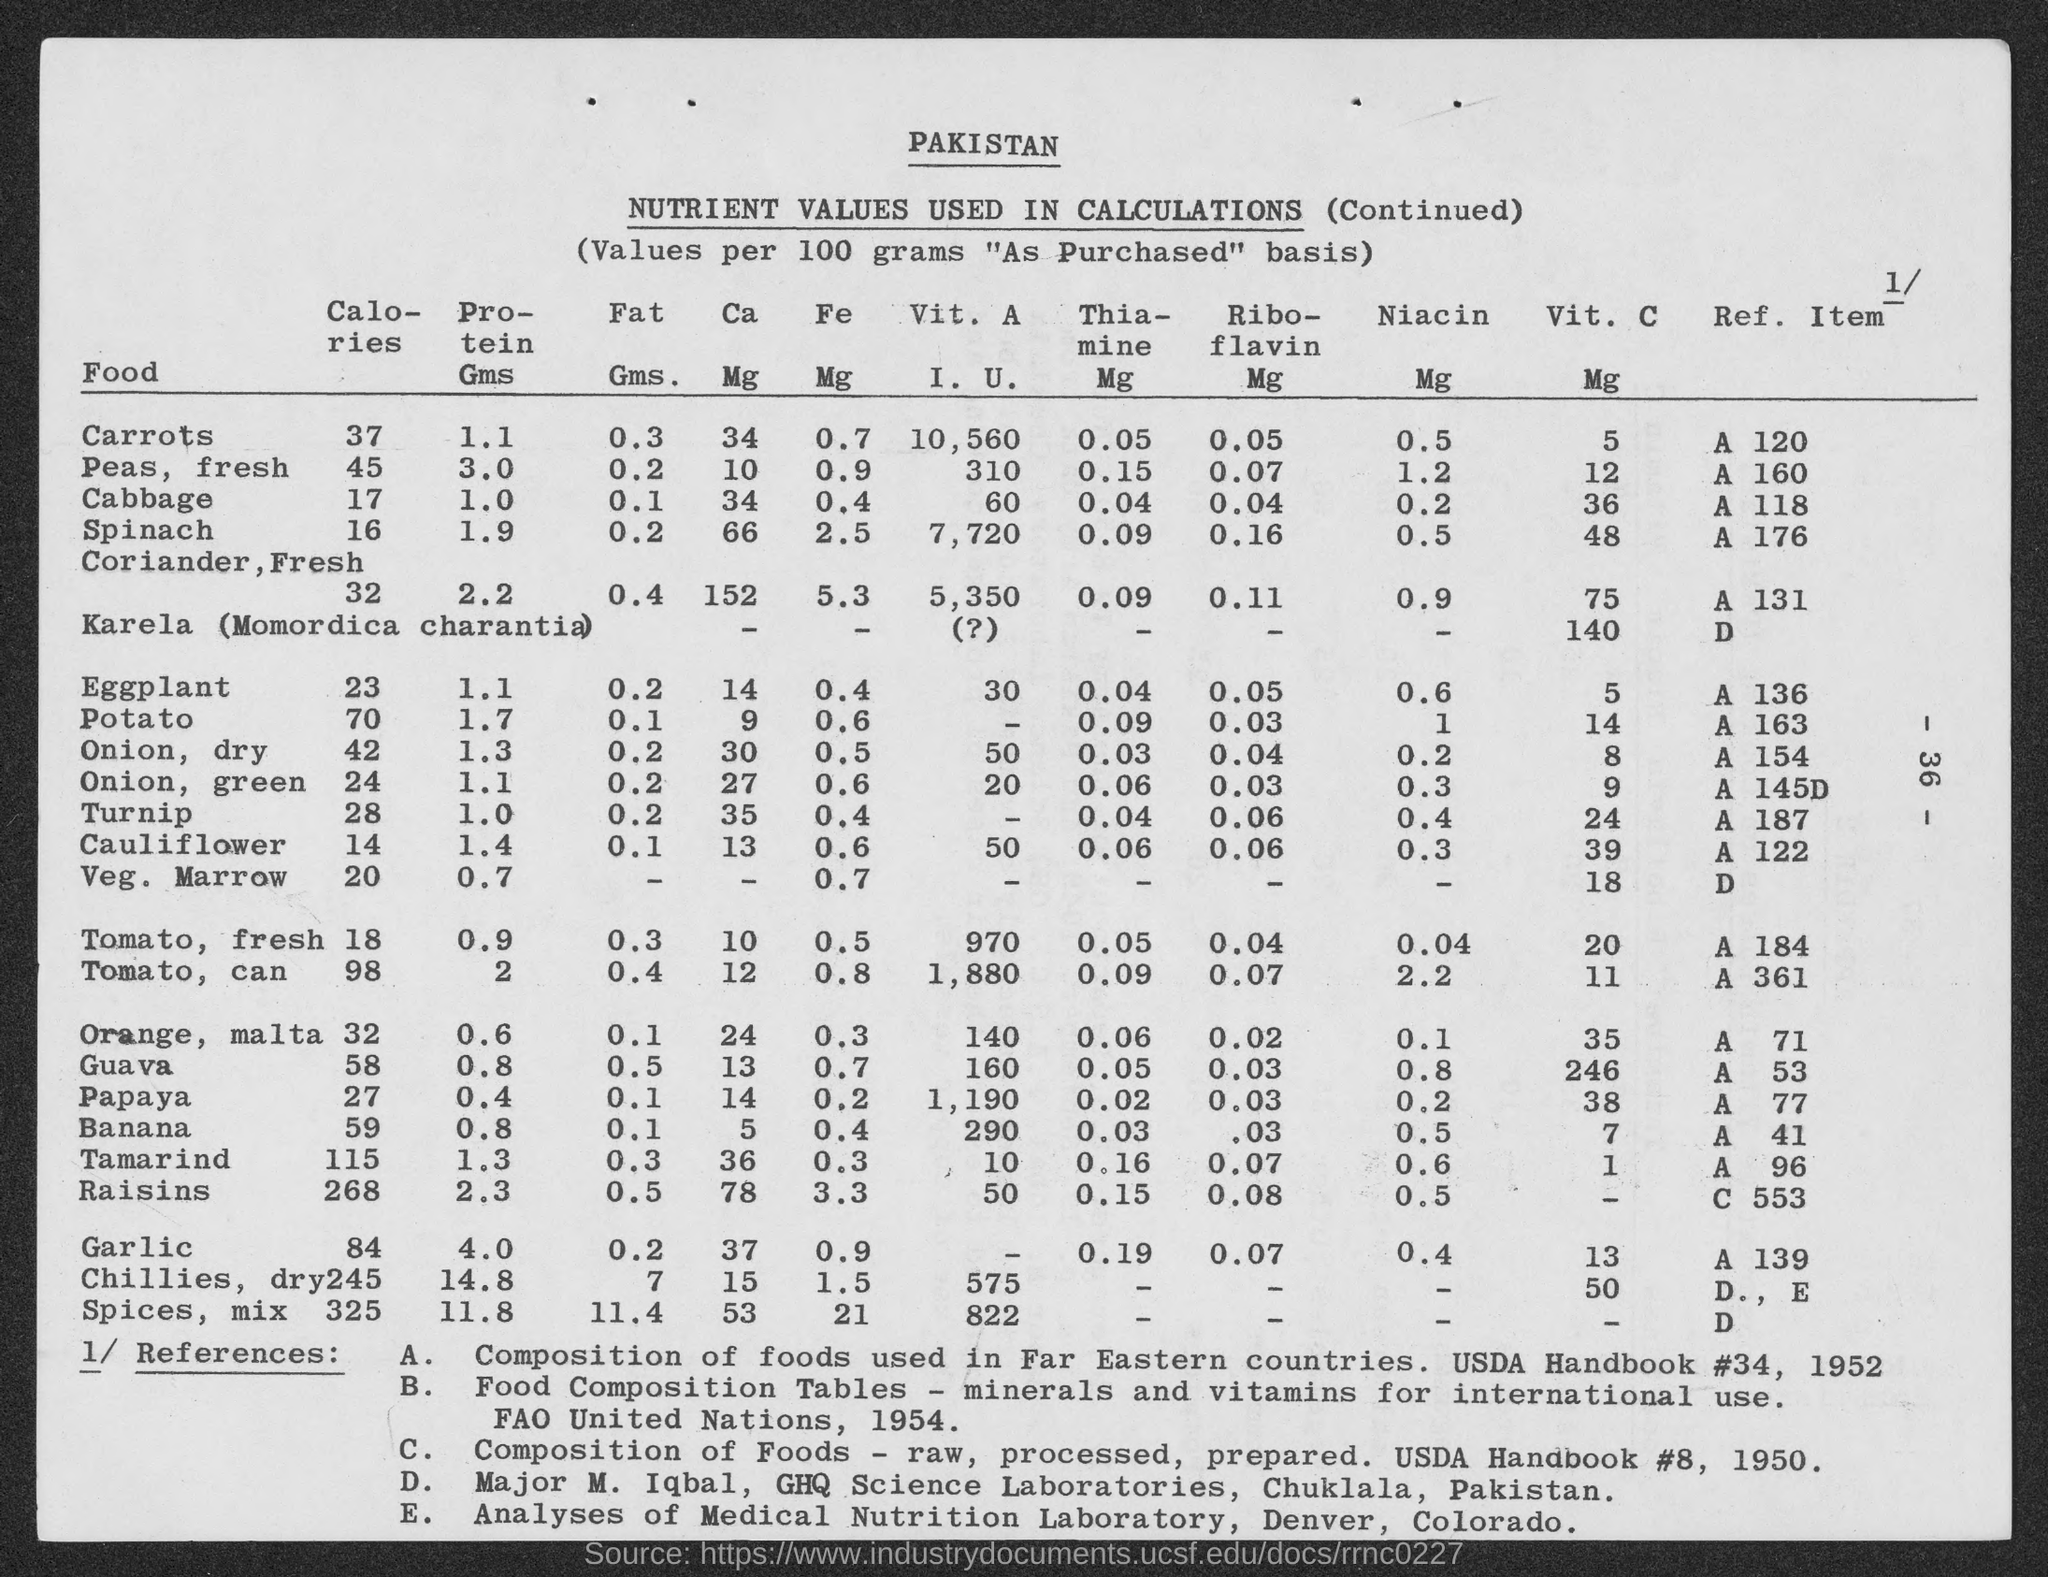Indicate a few pertinent items in this graphic. Item C 553 is associated with raisins as mentioned. The title of the first column, which is located on the left-hand side, is "Food". The reference E corresponds to the analyses of the Medical Nutrition Laboratory in Denver, Colorado. Approximately 70 calories are present in 100 grams of potato. There are 246 milligrams (mg) of vitamin C in 100 grams (g) of Gauva. 